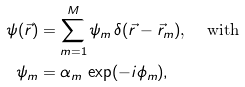Convert formula to latex. <formula><loc_0><loc_0><loc_500><loc_500>\psi ( \vec { r } ) & = \sum _ { m = 1 } ^ { M } \psi _ { m } \, \delta ( \vec { r } - \vec { r } _ { m } ) \text {, \quad with} \\ \psi _ { m } & = \alpha _ { m } \, \exp ( - i \phi _ { m } ) ,</formula> 